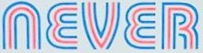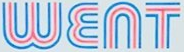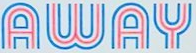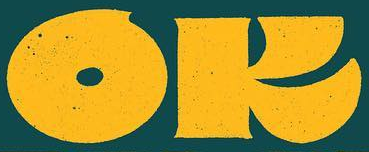What text is displayed in these images sequentially, separated by a semicolon? NEVER; WENT; AWAY; OK 